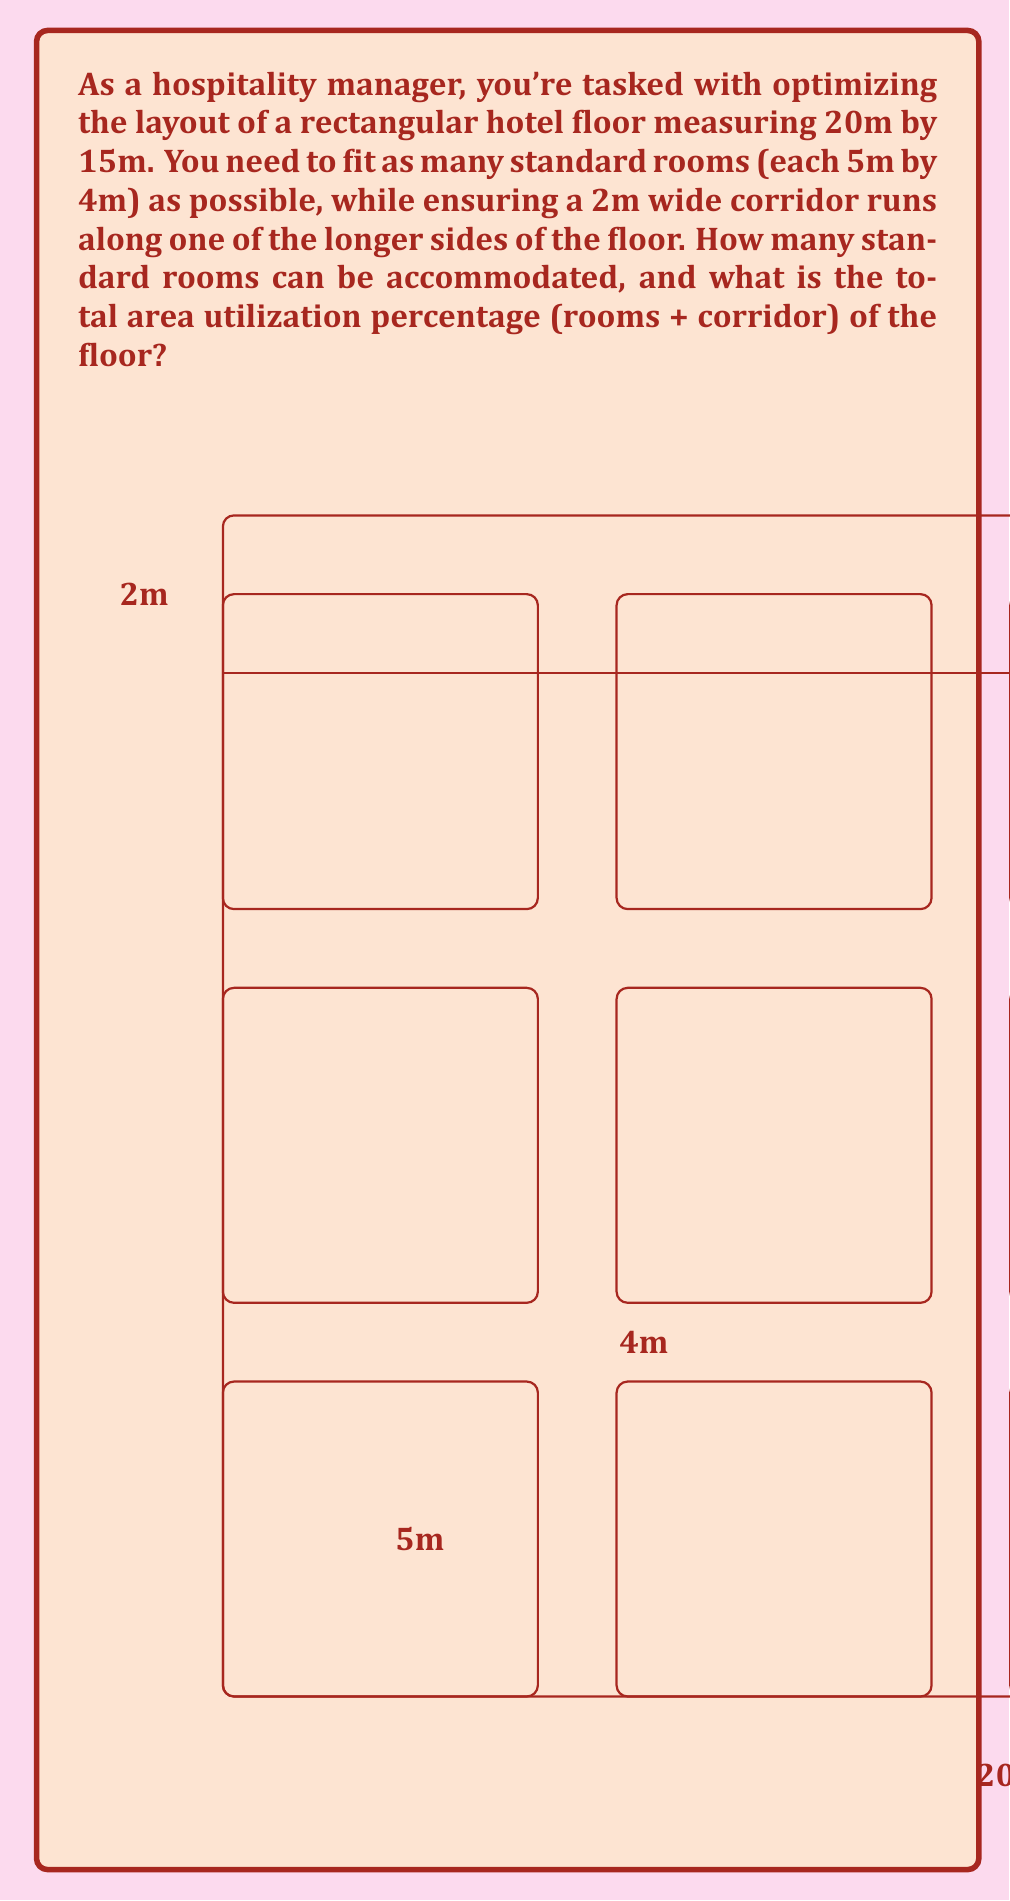Can you solve this math problem? Let's approach this step-by-step:

1) First, calculate the total floor area:
   $$A_{total} = 20m \times 15m = 300m^2$$

2) Calculate the corridor area:
   $$A_{corridor} = 20m \times 2m = 40m^2$$

3) Remaining area for rooms:
   $$A_{rooms} = A_{total} - A_{corridor} = 300m^2 - 40m^2 = 260m^2$$

4) Area of each standard room:
   $$A_{room} = 5m \times 4m = 20m^2$$

5) Number of rooms that can fit:
   $$N_{rooms} = \lfloor \frac{A_{rooms}}{A_{room}} \rfloor = \lfloor \frac{260m^2}{20m^2} \rfloor = 13$$
   (We use the floor function as we can't have partial rooms)

6) Total area utilized:
   $$A_{utilized} = (N_{rooms} \times A_{room}) + A_{corridor}$$
   $$A_{utilized} = (13 \times 20m^2) + 40m^2 = 300m^2$$

7) Area utilization percentage:
   $$\text{Utilization} = \frac{A_{utilized}}{A_{total}} \times 100\% = \frac{300m^2}{300m^2} \times 100\% = 100\%$$

Therefore, 13 standard rooms can be accommodated, and the total area utilization is 100%.
Answer: 13 rooms; 100% utilization 